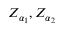<formula> <loc_0><loc_0><loc_500><loc_500>Z _ { \alpha _ { 1 } } , Z _ { \alpha _ { 2 } }</formula> 